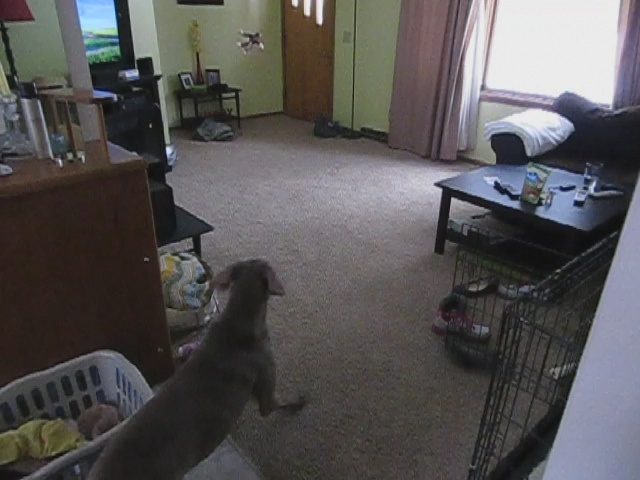Describe the objects in this image and their specific colors. I can see dog in black and gray tones, couch in black and gray tones, tv in black, lightblue, and teal tones, cup in black, gray, and darkgray tones, and cup in black, gray, and darkblue tones in this image. 